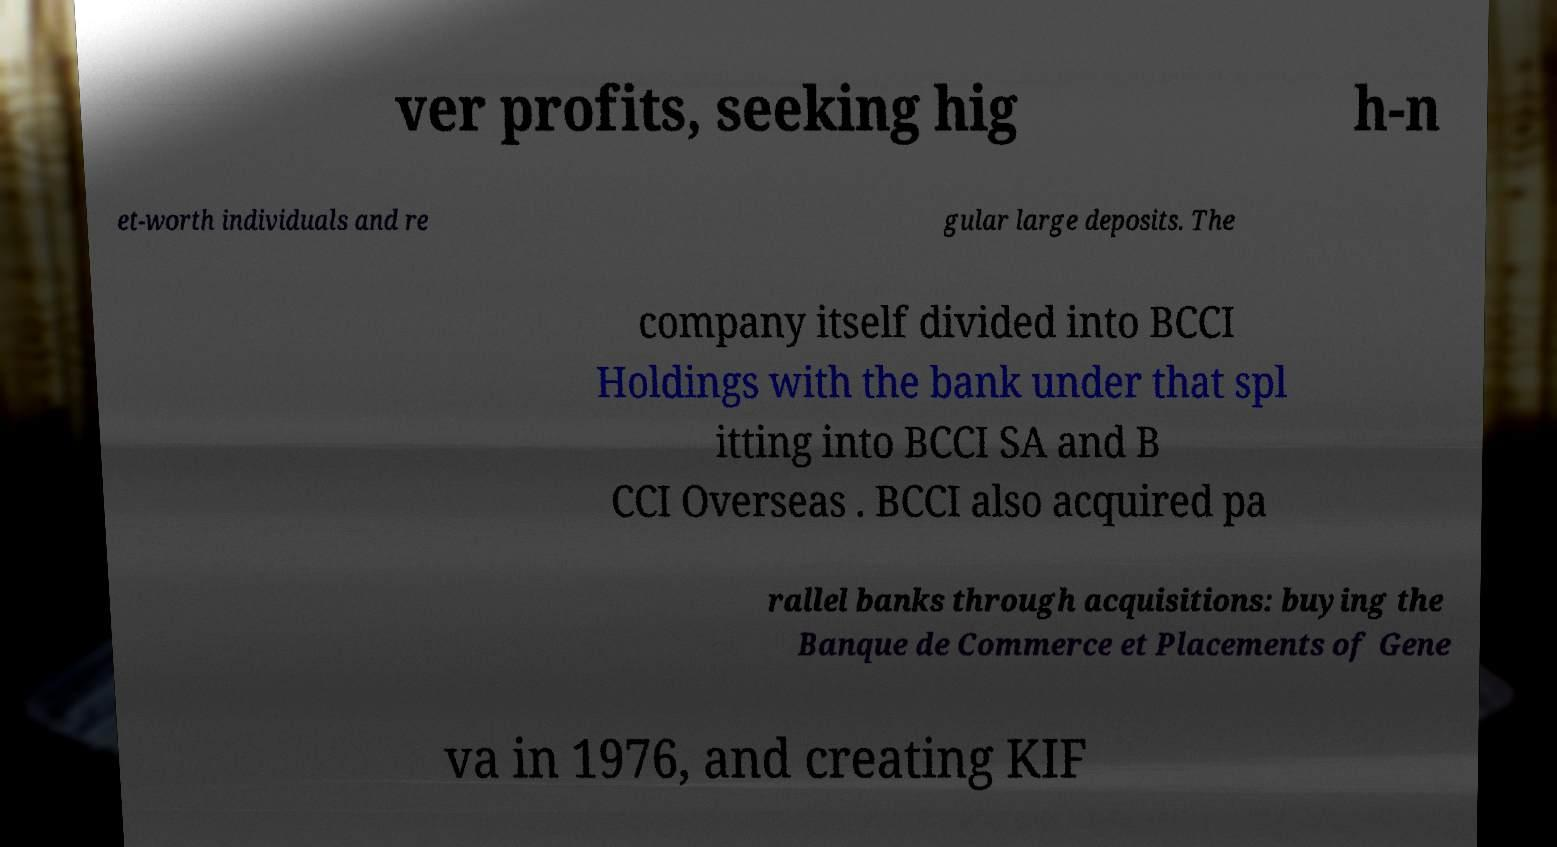Please read and relay the text visible in this image. What does it say? ver profits, seeking hig h-n et-worth individuals and re gular large deposits. The company itself divided into BCCI Holdings with the bank under that spl itting into BCCI SA and B CCI Overseas . BCCI also acquired pa rallel banks through acquisitions: buying the Banque de Commerce et Placements of Gene va in 1976, and creating KIF 